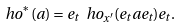Convert formula to latex. <formula><loc_0><loc_0><loc_500><loc_500>\ h o ^ { \ast } ( a ) = e _ { t } \ h o _ { x ^ { \prime } } ( e _ { t } a e _ { t } ) e _ { t } .</formula> 